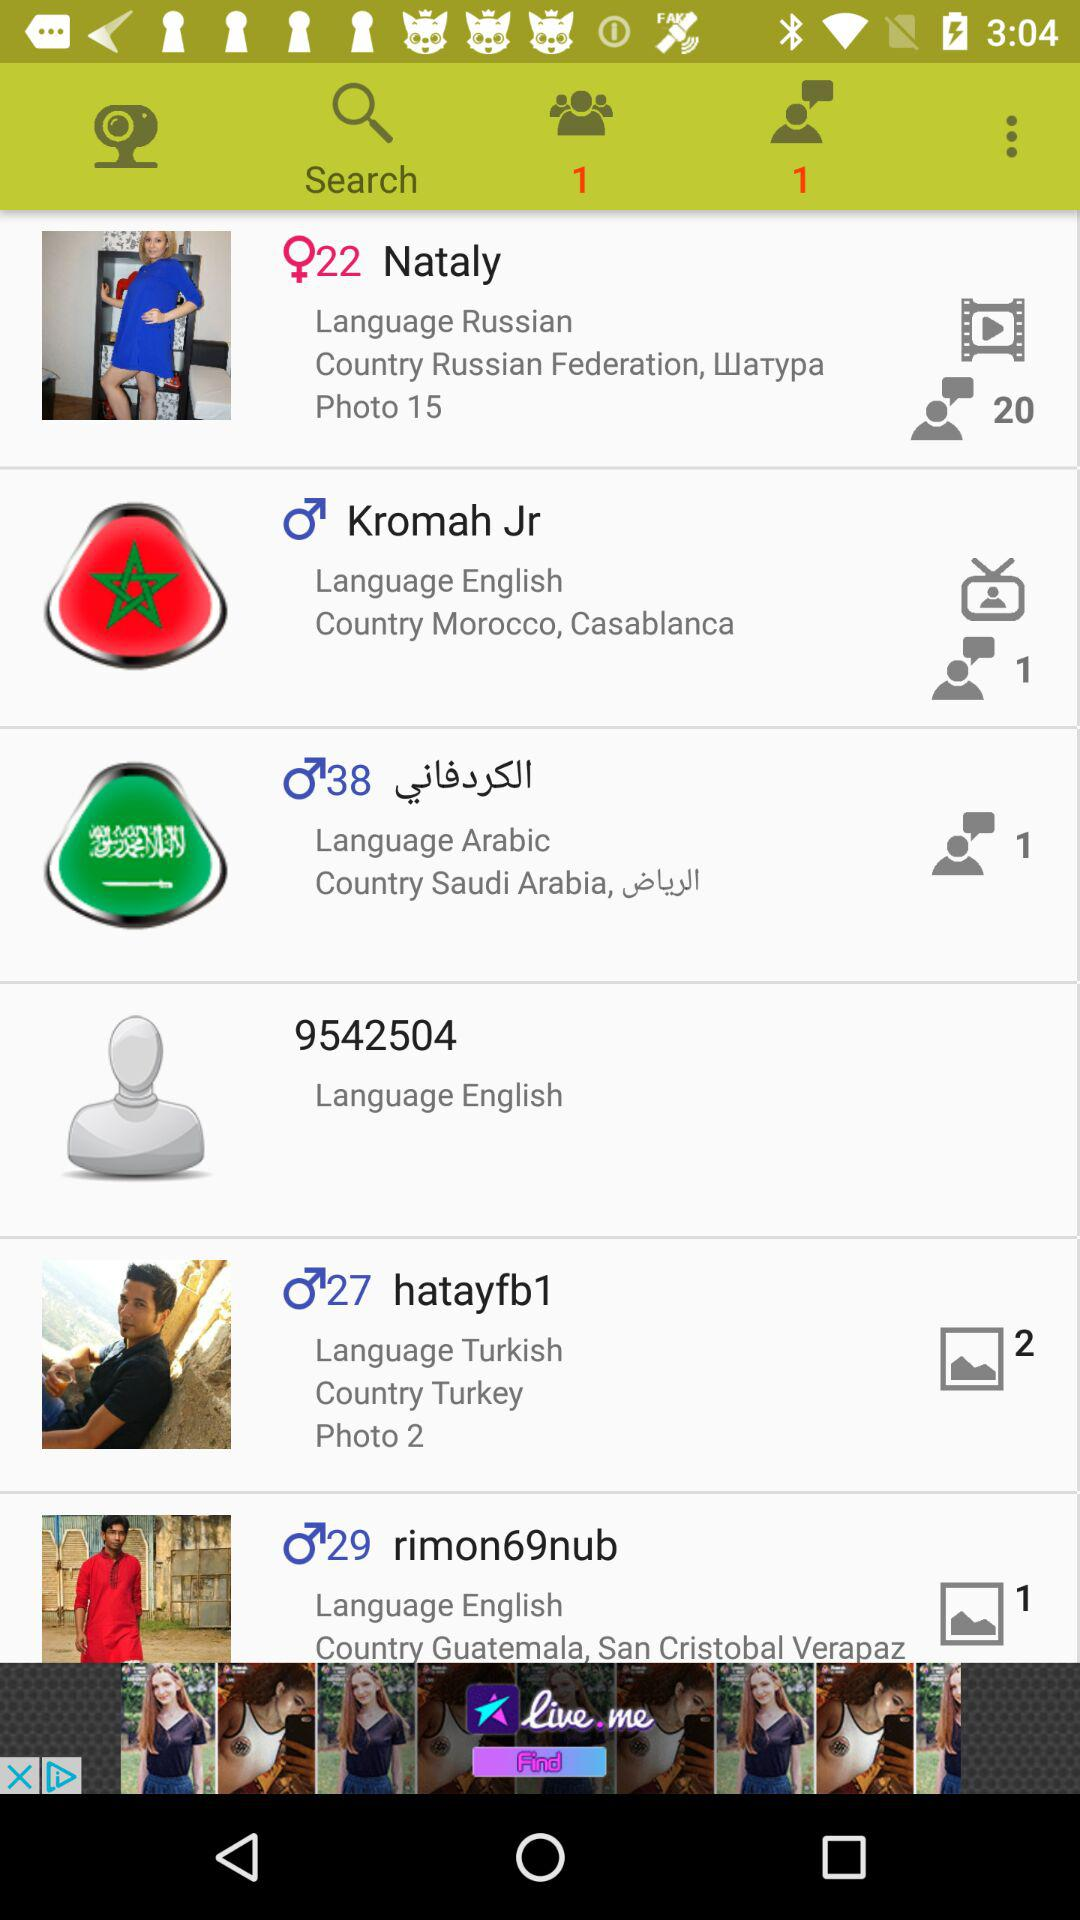Where does Kromah Jr. live? Kromah Jr. lives in Casablanca, Morocco. 